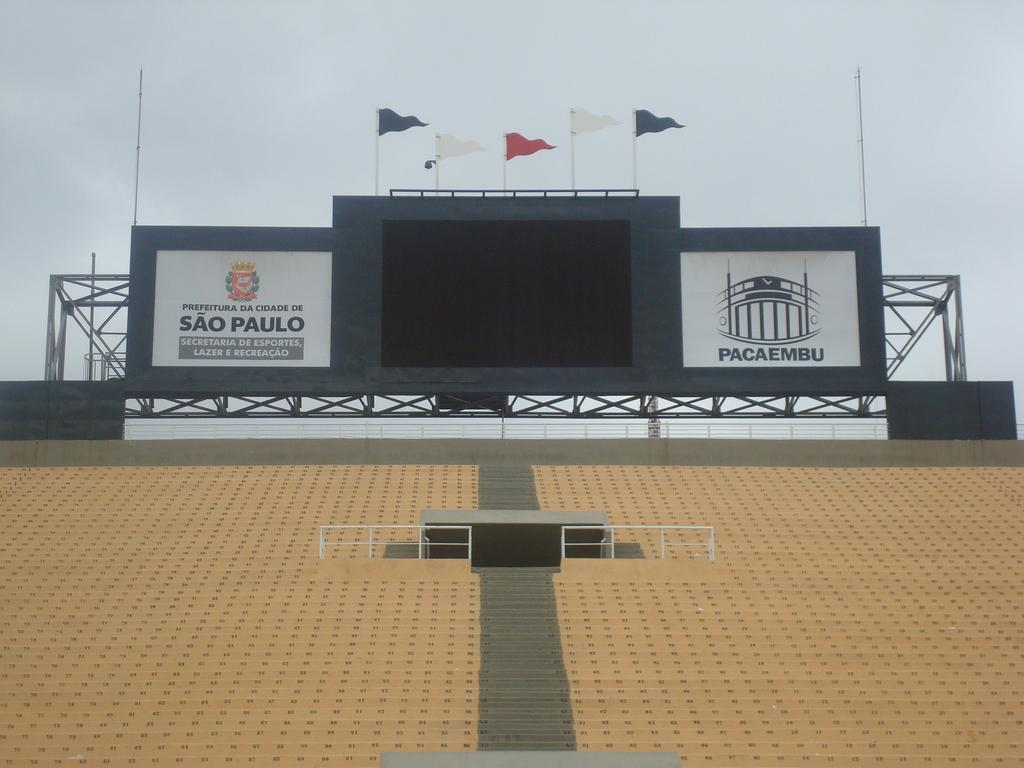<image>
Summarize the visual content of the image. The yellow seats are empty at the stadium in Sao Paulo. 